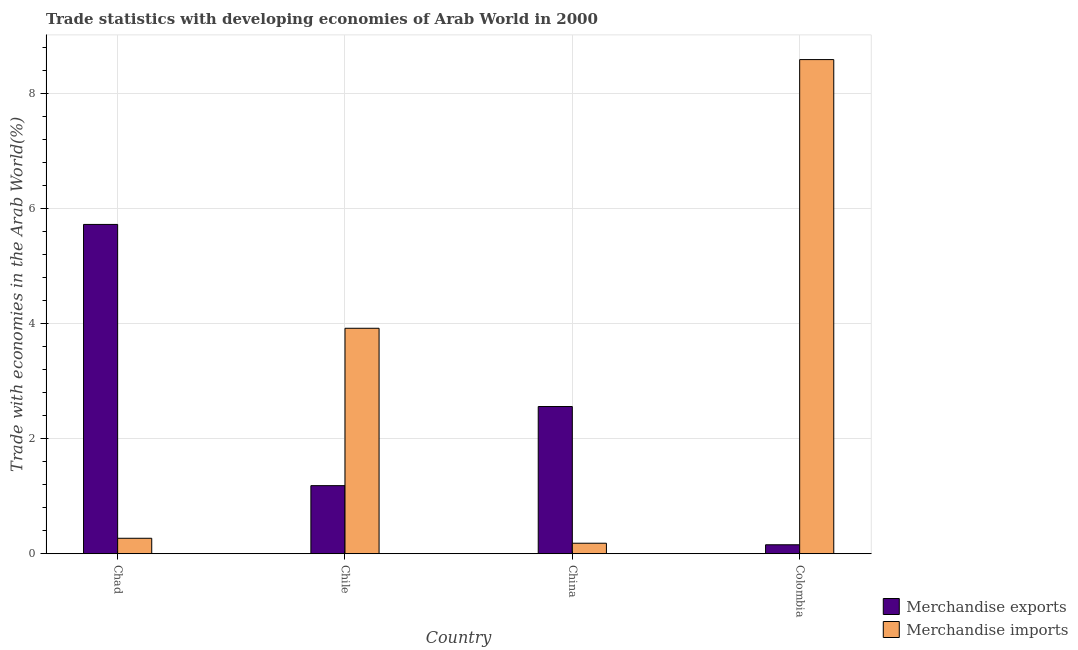How many different coloured bars are there?
Provide a short and direct response. 2. How many groups of bars are there?
Provide a short and direct response. 4. Are the number of bars per tick equal to the number of legend labels?
Offer a very short reply. Yes. How many bars are there on the 4th tick from the right?
Provide a succinct answer. 2. What is the label of the 1st group of bars from the left?
Offer a terse response. Chad. In how many cases, is the number of bars for a given country not equal to the number of legend labels?
Your answer should be compact. 0. What is the merchandise imports in Chile?
Offer a terse response. 3.92. Across all countries, what is the maximum merchandise imports?
Give a very brief answer. 8.58. Across all countries, what is the minimum merchandise exports?
Give a very brief answer. 0.16. What is the total merchandise exports in the graph?
Provide a short and direct response. 9.61. What is the difference between the merchandise imports in Chile and that in China?
Give a very brief answer. 3.73. What is the difference between the merchandise imports in Chad and the merchandise exports in Chile?
Your answer should be very brief. -0.91. What is the average merchandise imports per country?
Your answer should be very brief. 3.24. What is the difference between the merchandise imports and merchandise exports in China?
Your response must be concise. -2.37. What is the ratio of the merchandise exports in China to that in Colombia?
Your response must be concise. 16.43. Is the difference between the merchandise imports in Chad and Chile greater than the difference between the merchandise exports in Chad and Chile?
Ensure brevity in your answer.  No. What is the difference between the highest and the second highest merchandise imports?
Provide a succinct answer. 4.67. What is the difference between the highest and the lowest merchandise imports?
Your answer should be compact. 8.4. In how many countries, is the merchandise exports greater than the average merchandise exports taken over all countries?
Keep it short and to the point. 2. What does the 2nd bar from the right in Chile represents?
Provide a succinct answer. Merchandise exports. How many countries are there in the graph?
Your answer should be compact. 4. What is the difference between two consecutive major ticks on the Y-axis?
Offer a very short reply. 2. Are the values on the major ticks of Y-axis written in scientific E-notation?
Provide a short and direct response. No. Does the graph contain grids?
Provide a succinct answer. Yes. Where does the legend appear in the graph?
Your answer should be compact. Bottom right. How many legend labels are there?
Make the answer very short. 2. How are the legend labels stacked?
Provide a succinct answer. Vertical. What is the title of the graph?
Ensure brevity in your answer.  Trade statistics with developing economies of Arab World in 2000. What is the label or title of the X-axis?
Give a very brief answer. Country. What is the label or title of the Y-axis?
Offer a very short reply. Trade with economies in the Arab World(%). What is the Trade with economies in the Arab World(%) of Merchandise exports in Chad?
Ensure brevity in your answer.  5.72. What is the Trade with economies in the Arab World(%) in Merchandise imports in Chad?
Offer a very short reply. 0.27. What is the Trade with economies in the Arab World(%) of Merchandise exports in Chile?
Provide a succinct answer. 1.18. What is the Trade with economies in the Arab World(%) of Merchandise imports in Chile?
Offer a very short reply. 3.92. What is the Trade with economies in the Arab World(%) in Merchandise exports in China?
Your response must be concise. 2.56. What is the Trade with economies in the Arab World(%) in Merchandise imports in China?
Ensure brevity in your answer.  0.18. What is the Trade with economies in the Arab World(%) in Merchandise exports in Colombia?
Your response must be concise. 0.16. What is the Trade with economies in the Arab World(%) of Merchandise imports in Colombia?
Your response must be concise. 8.58. Across all countries, what is the maximum Trade with economies in the Arab World(%) of Merchandise exports?
Provide a short and direct response. 5.72. Across all countries, what is the maximum Trade with economies in the Arab World(%) in Merchandise imports?
Your response must be concise. 8.58. Across all countries, what is the minimum Trade with economies in the Arab World(%) in Merchandise exports?
Provide a succinct answer. 0.16. Across all countries, what is the minimum Trade with economies in the Arab World(%) of Merchandise imports?
Your answer should be compact. 0.18. What is the total Trade with economies in the Arab World(%) in Merchandise exports in the graph?
Your response must be concise. 9.61. What is the total Trade with economies in the Arab World(%) in Merchandise imports in the graph?
Give a very brief answer. 12.95. What is the difference between the Trade with economies in the Arab World(%) in Merchandise exports in Chad and that in Chile?
Keep it short and to the point. 4.54. What is the difference between the Trade with economies in the Arab World(%) in Merchandise imports in Chad and that in Chile?
Keep it short and to the point. -3.65. What is the difference between the Trade with economies in the Arab World(%) of Merchandise exports in Chad and that in China?
Offer a very short reply. 3.16. What is the difference between the Trade with economies in the Arab World(%) in Merchandise imports in Chad and that in China?
Offer a very short reply. 0.09. What is the difference between the Trade with economies in the Arab World(%) in Merchandise exports in Chad and that in Colombia?
Provide a succinct answer. 5.56. What is the difference between the Trade with economies in the Arab World(%) of Merchandise imports in Chad and that in Colombia?
Make the answer very short. -8.31. What is the difference between the Trade with economies in the Arab World(%) of Merchandise exports in Chile and that in China?
Provide a succinct answer. -1.37. What is the difference between the Trade with economies in the Arab World(%) in Merchandise imports in Chile and that in China?
Offer a very short reply. 3.73. What is the difference between the Trade with economies in the Arab World(%) of Merchandise imports in Chile and that in Colombia?
Provide a succinct answer. -4.67. What is the difference between the Trade with economies in the Arab World(%) in Merchandise exports in China and that in Colombia?
Provide a short and direct response. 2.4. What is the difference between the Trade with economies in the Arab World(%) in Merchandise imports in China and that in Colombia?
Provide a short and direct response. -8.4. What is the difference between the Trade with economies in the Arab World(%) of Merchandise exports in Chad and the Trade with economies in the Arab World(%) of Merchandise imports in Chile?
Ensure brevity in your answer.  1.8. What is the difference between the Trade with economies in the Arab World(%) of Merchandise exports in Chad and the Trade with economies in the Arab World(%) of Merchandise imports in China?
Provide a short and direct response. 5.54. What is the difference between the Trade with economies in the Arab World(%) of Merchandise exports in Chad and the Trade with economies in the Arab World(%) of Merchandise imports in Colombia?
Offer a very short reply. -2.86. What is the difference between the Trade with economies in the Arab World(%) of Merchandise exports in Chile and the Trade with economies in the Arab World(%) of Merchandise imports in China?
Keep it short and to the point. 1. What is the difference between the Trade with economies in the Arab World(%) of Merchandise exports in Chile and the Trade with economies in the Arab World(%) of Merchandise imports in Colombia?
Keep it short and to the point. -7.4. What is the difference between the Trade with economies in the Arab World(%) of Merchandise exports in China and the Trade with economies in the Arab World(%) of Merchandise imports in Colombia?
Provide a short and direct response. -6.03. What is the average Trade with economies in the Arab World(%) in Merchandise exports per country?
Provide a succinct answer. 2.4. What is the average Trade with economies in the Arab World(%) of Merchandise imports per country?
Offer a terse response. 3.24. What is the difference between the Trade with economies in the Arab World(%) of Merchandise exports and Trade with economies in the Arab World(%) of Merchandise imports in Chad?
Keep it short and to the point. 5.45. What is the difference between the Trade with economies in the Arab World(%) of Merchandise exports and Trade with economies in the Arab World(%) of Merchandise imports in Chile?
Your response must be concise. -2.73. What is the difference between the Trade with economies in the Arab World(%) in Merchandise exports and Trade with economies in the Arab World(%) in Merchandise imports in China?
Provide a succinct answer. 2.37. What is the difference between the Trade with economies in the Arab World(%) in Merchandise exports and Trade with economies in the Arab World(%) in Merchandise imports in Colombia?
Keep it short and to the point. -8.43. What is the ratio of the Trade with economies in the Arab World(%) of Merchandise exports in Chad to that in Chile?
Your response must be concise. 4.84. What is the ratio of the Trade with economies in the Arab World(%) of Merchandise imports in Chad to that in Chile?
Ensure brevity in your answer.  0.07. What is the ratio of the Trade with economies in the Arab World(%) of Merchandise exports in Chad to that in China?
Offer a terse response. 2.24. What is the ratio of the Trade with economies in the Arab World(%) in Merchandise imports in Chad to that in China?
Give a very brief answer. 1.47. What is the ratio of the Trade with economies in the Arab World(%) of Merchandise exports in Chad to that in Colombia?
Ensure brevity in your answer.  36.76. What is the ratio of the Trade with economies in the Arab World(%) of Merchandise imports in Chad to that in Colombia?
Offer a very short reply. 0.03. What is the ratio of the Trade with economies in the Arab World(%) of Merchandise exports in Chile to that in China?
Provide a short and direct response. 0.46. What is the ratio of the Trade with economies in the Arab World(%) of Merchandise imports in Chile to that in China?
Provide a succinct answer. 21.46. What is the ratio of the Trade with economies in the Arab World(%) of Merchandise exports in Chile to that in Colombia?
Keep it short and to the point. 7.6. What is the ratio of the Trade with economies in the Arab World(%) of Merchandise imports in Chile to that in Colombia?
Provide a short and direct response. 0.46. What is the ratio of the Trade with economies in the Arab World(%) of Merchandise exports in China to that in Colombia?
Offer a terse response. 16.43. What is the ratio of the Trade with economies in the Arab World(%) of Merchandise imports in China to that in Colombia?
Offer a very short reply. 0.02. What is the difference between the highest and the second highest Trade with economies in the Arab World(%) of Merchandise exports?
Offer a very short reply. 3.16. What is the difference between the highest and the second highest Trade with economies in the Arab World(%) of Merchandise imports?
Your response must be concise. 4.67. What is the difference between the highest and the lowest Trade with economies in the Arab World(%) of Merchandise exports?
Make the answer very short. 5.56. What is the difference between the highest and the lowest Trade with economies in the Arab World(%) of Merchandise imports?
Your answer should be very brief. 8.4. 